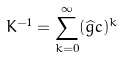Convert formula to latex. <formula><loc_0><loc_0><loc_500><loc_500>K ^ { - 1 } = \sum _ { k = 0 } ^ { \infty } ( \widehat { g } c ) ^ { k }</formula> 